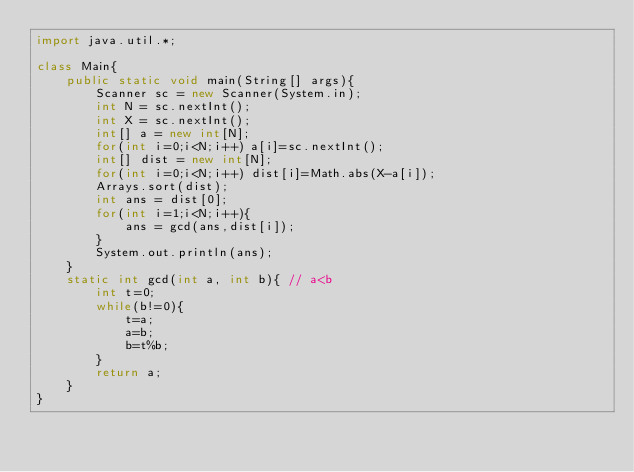<code> <loc_0><loc_0><loc_500><loc_500><_Java_>import java.util.*;

class Main{
    public static void main(String[] args){
        Scanner sc = new Scanner(System.in);
        int N = sc.nextInt();
        int X = sc.nextInt();
        int[] a = new int[N];
        for(int i=0;i<N;i++) a[i]=sc.nextInt();
        int[] dist = new int[N];
        for(int i=0;i<N;i++) dist[i]=Math.abs(X-a[i]);
        Arrays.sort(dist);
        int ans = dist[0];
        for(int i=1;i<N;i++){
            ans = gcd(ans,dist[i]);
        }
        System.out.println(ans);
    }
    static int gcd(int a, int b){ // a<b
        int t=0;
        while(b!=0){
            t=a;
            a=b;
            b=t%b;
        }
        return a;
    }
}

</code> 